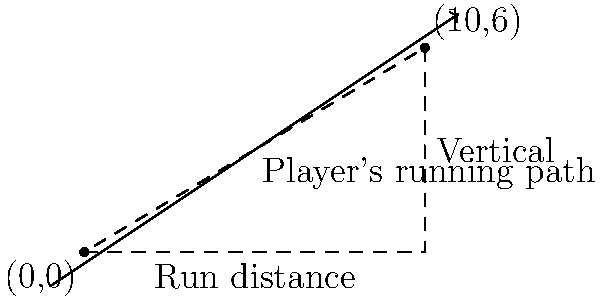During a match, you observed a player's straight running path from one point on the pitch to another. The starting point is at (0,0) and the ending point is at (10,6), where the units are in meters. Calculate the slope of the line representing the player's running path. To calculate the slope of the line representing the player's running path, we'll use the slope formula:

$$m = \frac{y_2 - y_1}{x_2 - x_1}$$

Where:
$(x_1, y_1)$ is the starting point (0,0)
$(x_2, y_2)$ is the ending point (10,6)

Let's substitute these values into the formula:

$$m = \frac{6 - 0}{10 - 0} = \frac{6}{10}$$

Simplifying the fraction:

$$m = \frac{3}{5} = 0.6$$

The slope represents the rate of vertical change (rise) to horizontal change (run). In this case, for every 5 meters the player runs horizontally, they gain 3 meters in vertical distance.
Answer: $\frac{3}{5}$ or 0.6 